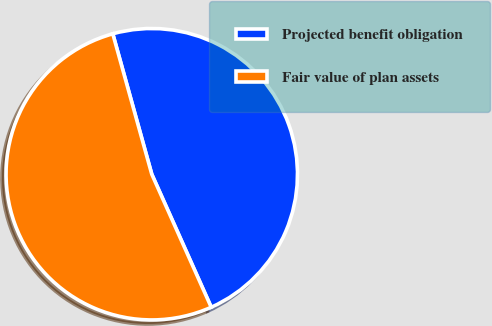Convert chart. <chart><loc_0><loc_0><loc_500><loc_500><pie_chart><fcel>Projected benefit obligation<fcel>Fair value of plan assets<nl><fcel>47.62%<fcel>52.38%<nl></chart> 